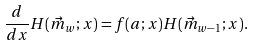<formula> <loc_0><loc_0><loc_500><loc_500>\frac { d } { d x } H ( \vec { m } _ { w } ; x ) = f ( a ; x ) H ( \vec { m } _ { w - 1 } ; x ) .</formula> 